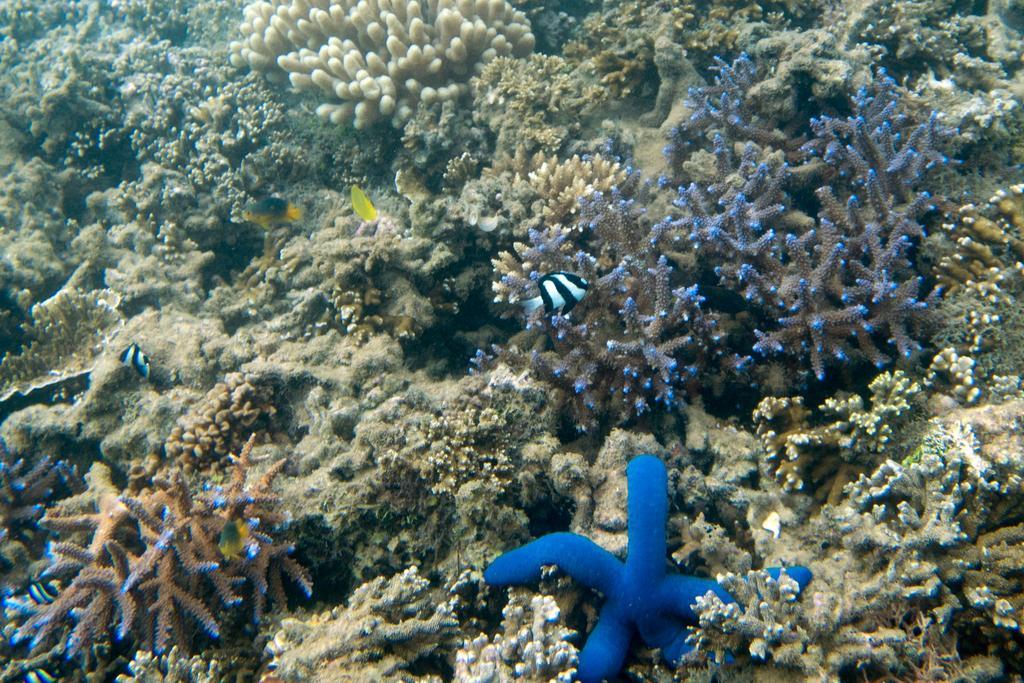How would you summarize this image in a sentence or two? In this picture we can see plants and fish. 